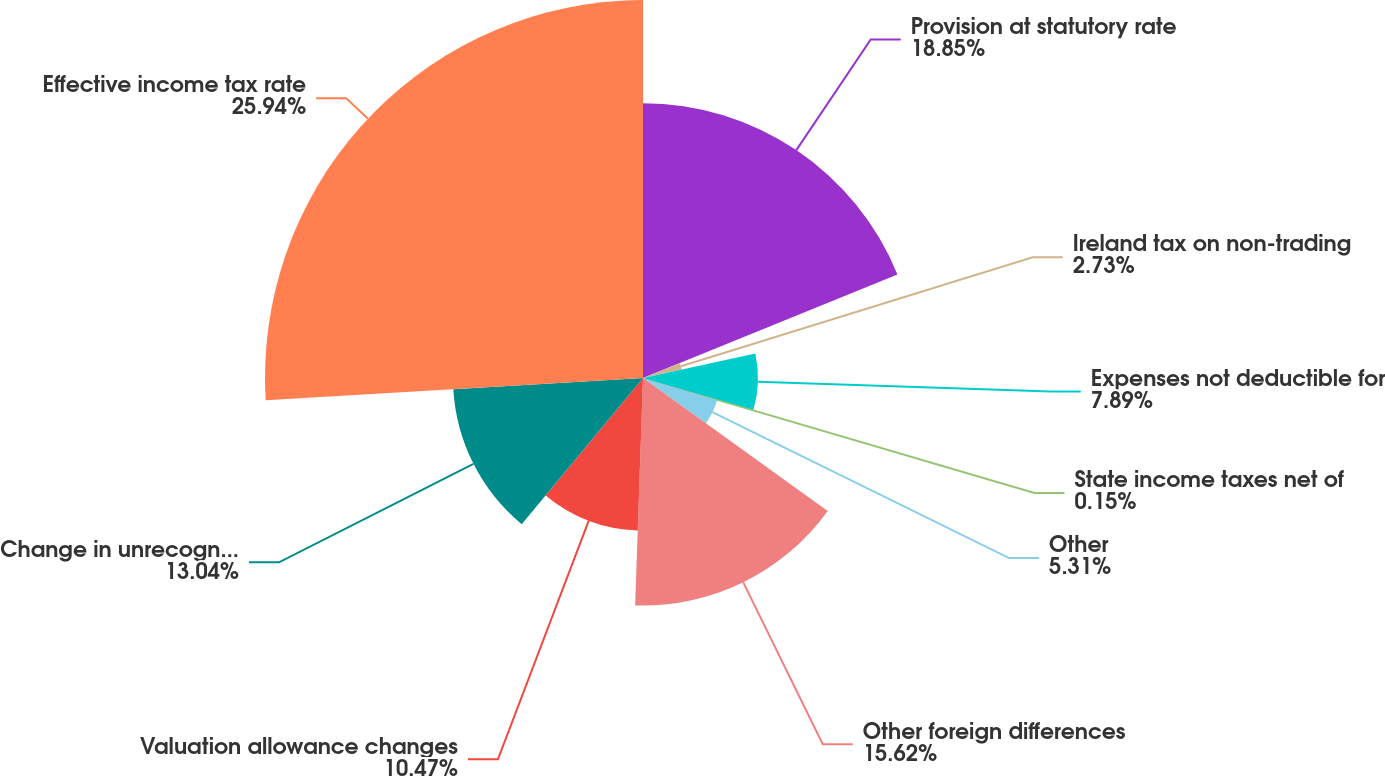Convert chart. <chart><loc_0><loc_0><loc_500><loc_500><pie_chart><fcel>Provision at statutory rate<fcel>Ireland tax on non-trading<fcel>Expenses not deductible for<fcel>State income taxes net of<fcel>Other<fcel>Other foreign differences<fcel>Valuation allowance changes<fcel>Change in unrecognized taxes<fcel>Effective income tax rate<nl><fcel>18.85%<fcel>2.73%<fcel>7.89%<fcel>0.15%<fcel>5.31%<fcel>15.62%<fcel>10.47%<fcel>13.04%<fcel>25.94%<nl></chart> 